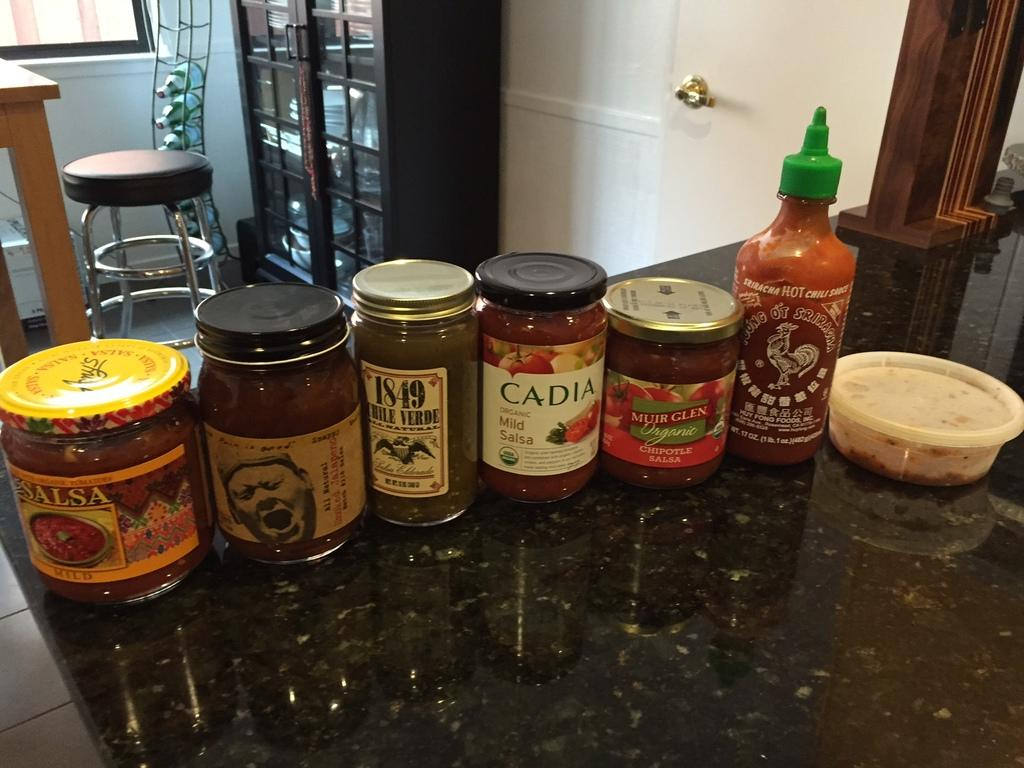What objects can be seen in the image? There are bottles, a table, and a stool in the image. Can you describe the table in the image? There is a table in the image, but no specific details about its size, shape, or color are provided. What is the purpose of the stool in the image? The purpose of the stool in the image is not explicitly stated, but it could be used for sitting or as a support for other objects. What type of jam is being spread on the bed in the image? There is no bed or jam present in the image; it only features bottles, a table, and a stool. 